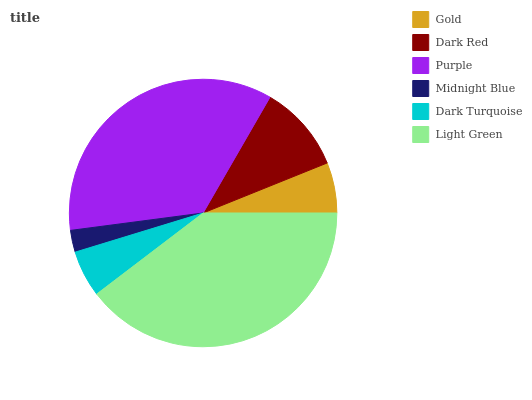Is Midnight Blue the minimum?
Answer yes or no. Yes. Is Light Green the maximum?
Answer yes or no. Yes. Is Dark Red the minimum?
Answer yes or no. No. Is Dark Red the maximum?
Answer yes or no. No. Is Dark Red greater than Gold?
Answer yes or no. Yes. Is Gold less than Dark Red?
Answer yes or no. Yes. Is Gold greater than Dark Red?
Answer yes or no. No. Is Dark Red less than Gold?
Answer yes or no. No. Is Dark Red the high median?
Answer yes or no. Yes. Is Gold the low median?
Answer yes or no. Yes. Is Gold the high median?
Answer yes or no. No. Is Purple the low median?
Answer yes or no. No. 